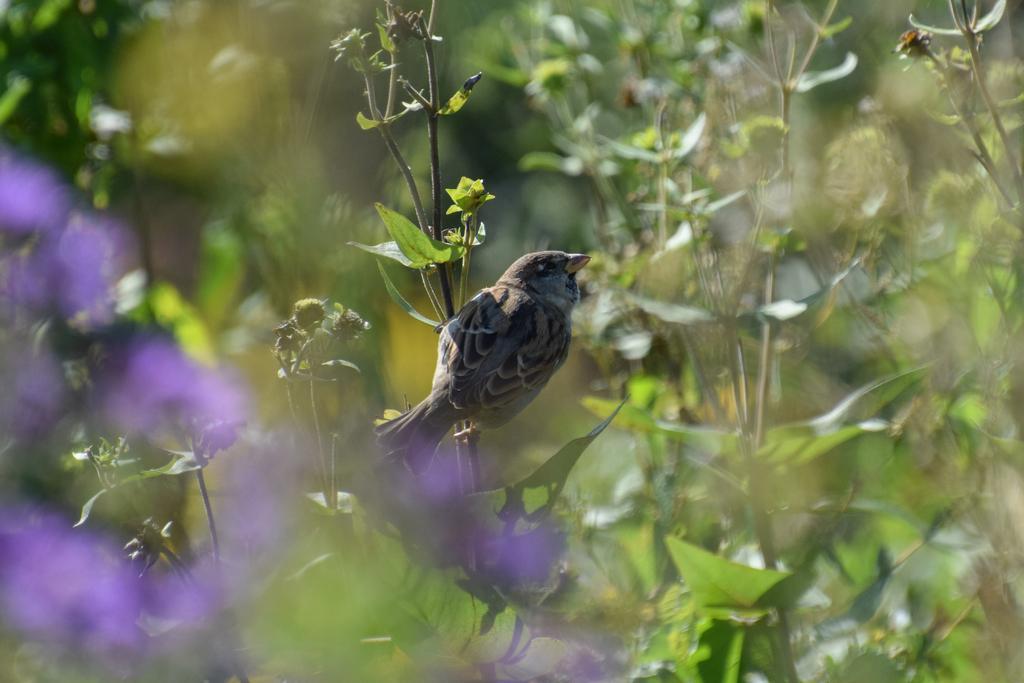Can you describe this image briefly? In the image we can see in front the image is blurred and there is a bird sitting on the plant. Behind there are plants. 